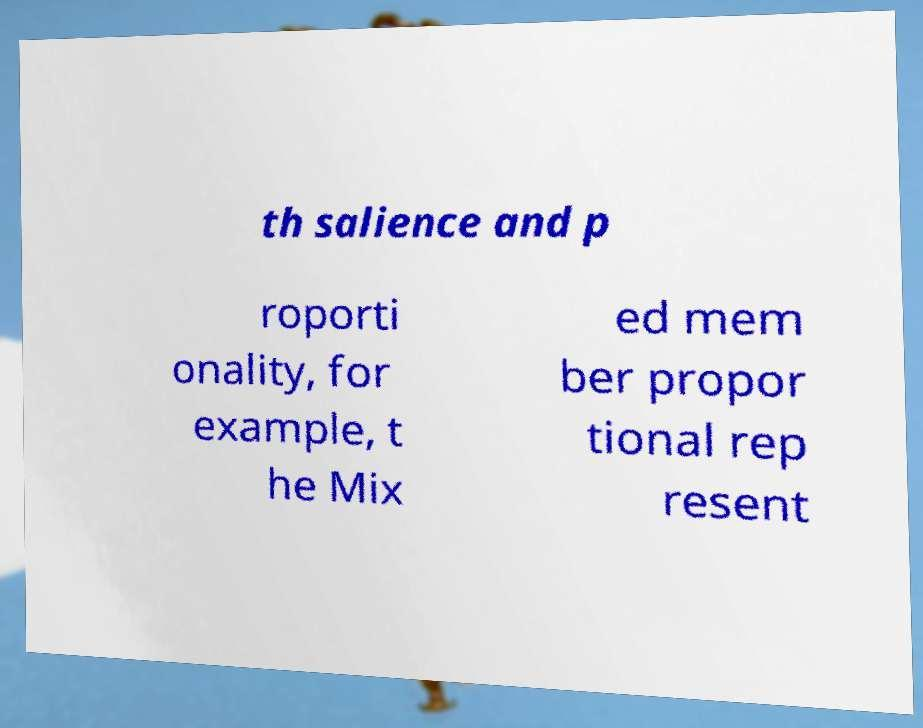What messages or text are displayed in this image? I need them in a readable, typed format. th salience and p roporti onality, for example, t he Mix ed mem ber propor tional rep resent 